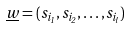Convert formula to latex. <formula><loc_0><loc_0><loc_500><loc_500>\underline { w } = ( s _ { i _ { 1 } } , s _ { i _ { 2 } } , \dots , s _ { i _ { l } } )</formula> 